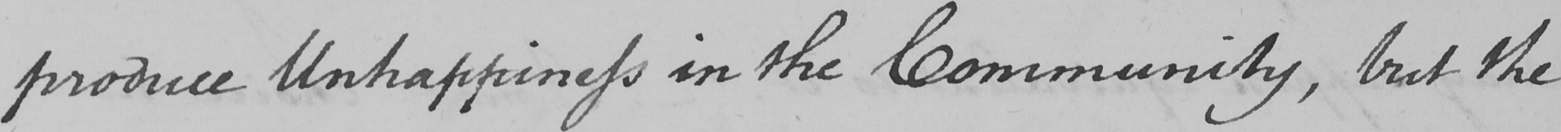What text is written in this handwritten line? produce Unhappiness in the Community , but the 